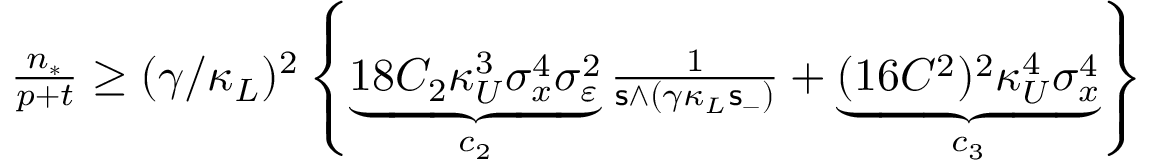<formula> <loc_0><loc_0><loc_500><loc_500>\begin{array} { r } { \frac { n _ { * } } { p + t } \geq ( \gamma / \kappa _ { L } ) ^ { 2 } \left \{ \underbrace { 1 8 C _ { 2 } \kappa _ { U } ^ { 3 } \sigma _ { x } ^ { 4 } \sigma _ { \varepsilon } ^ { 2 } } _ { c _ { 2 } } \frac { 1 } { s \land ( \gamma \kappa _ { L } s _ { - } ) } + \underbrace { ( 1 6 C ^ { 2 } ) ^ { 2 } \kappa _ { U } ^ { 4 } \sigma _ { x } ^ { 4 } } _ { c _ { 3 } } \right \} } \end{array}</formula> 